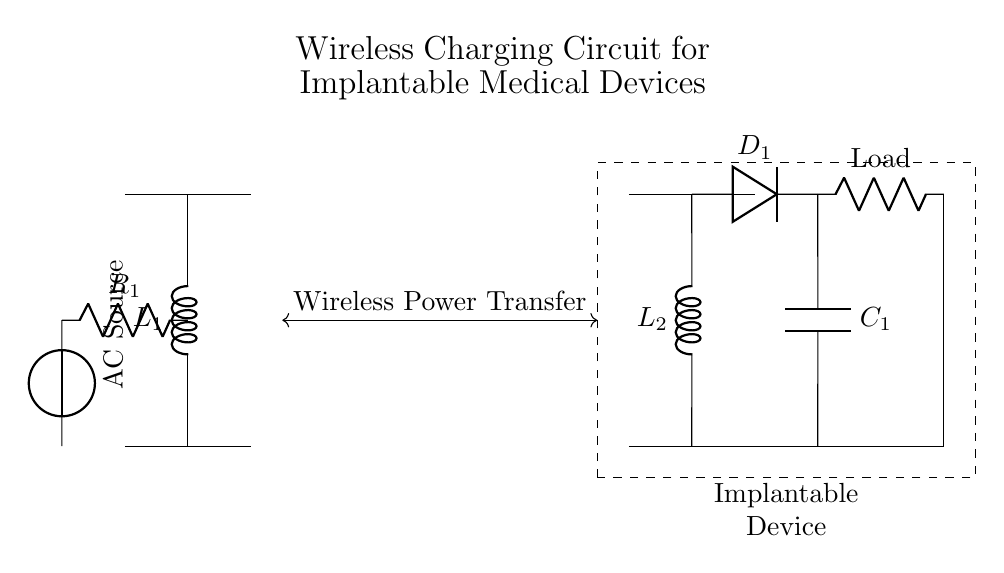What is the type of source used in the transmitter circuit? The diagram shows an AC source connected at the left of the transmitter circuit, which is fundamental for generating alternating current required for inductive coupling in wireless charging.
Answer: AC source What component is used to rectify the output in the receiver circuit? The circuit includes a diode labeled D1 in the receiver circuit. Diodes are used to allow current to flow in one direction and block it in the opposite, effectively converting AC to DC.
Answer: Diode How many inductors are present in this circuit? The circuit contains two inductors, L1 in the transmitter and L2 in the receiver, which are essential for wireless power transfer through electromagnetic induction.
Answer: Two What is the purpose of the capacitor in the receiver side? The capacitor labeled C1 is used for smoothing and stabilizing the output voltage after rectification, providing a more constant DC voltage to the load.
Answer: Smoothing What is the load connected to in the circuit? The load does not have a specific resistance value in the diagram, but it is represented as a resistor, indicating it draws current from the circuit and represents the implantable device’s power requirements.
Answer: Resistor What is the function of the dashed rectangle in the circuit? The dashed rectangle indicates the boundary of the implantable device, visually distinguishing the active elements within the circuit that are intended to be housed inside the medical device from the surrounding components.
Answer: Implantable device boundary 